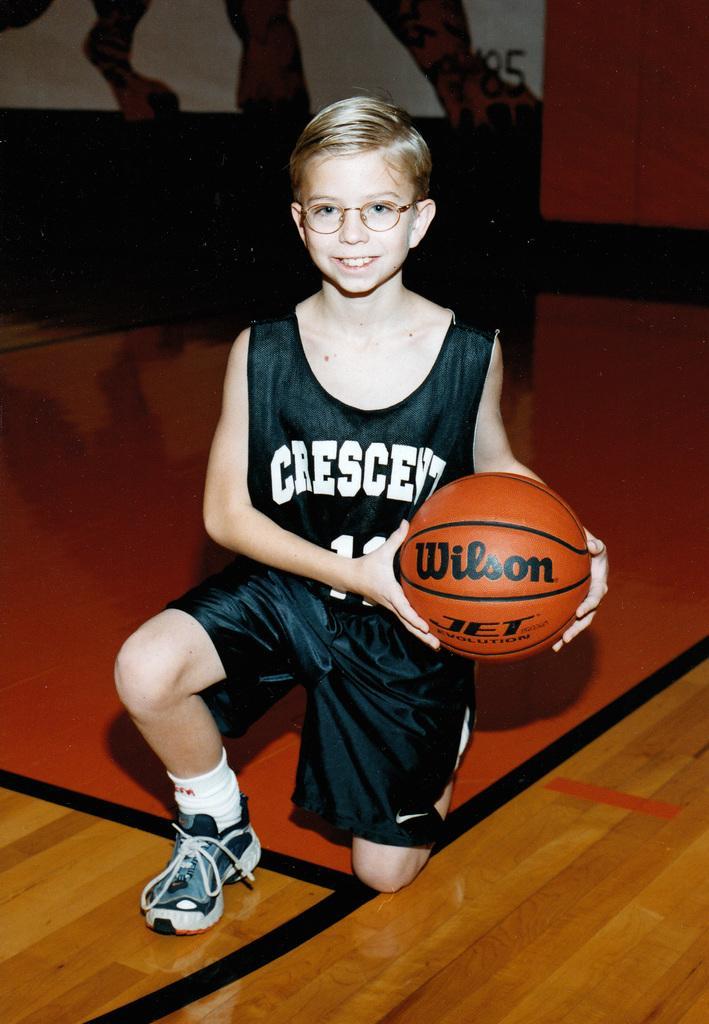How would you summarize this image in a sentence or two? In the middle of the image a boy holding a ball, Behind him there is a banner. 